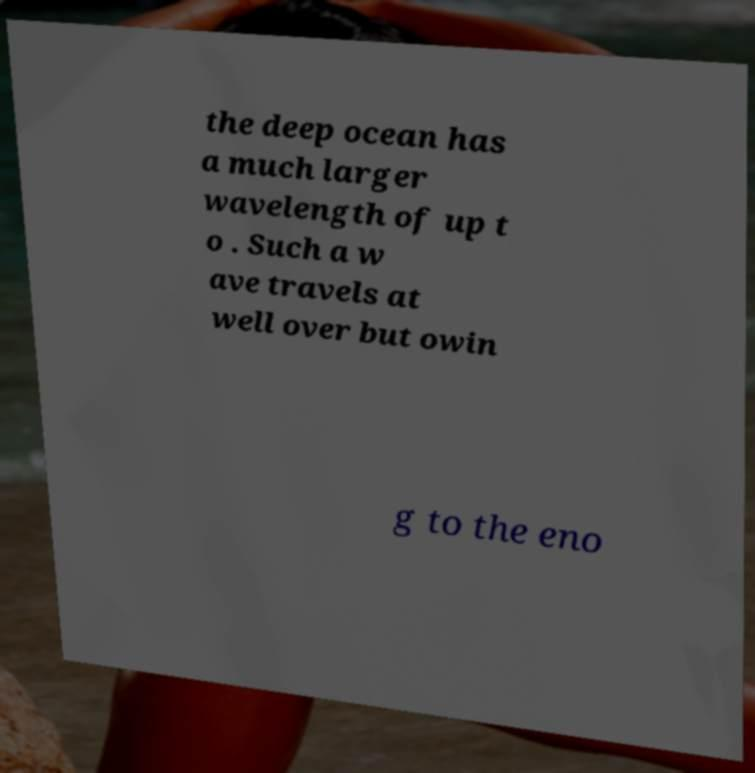Please identify and transcribe the text found in this image. the deep ocean has a much larger wavelength of up t o . Such a w ave travels at well over but owin g to the eno 